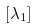<formula> <loc_0><loc_0><loc_500><loc_500>[ \lambda _ { 1 } ]</formula> 